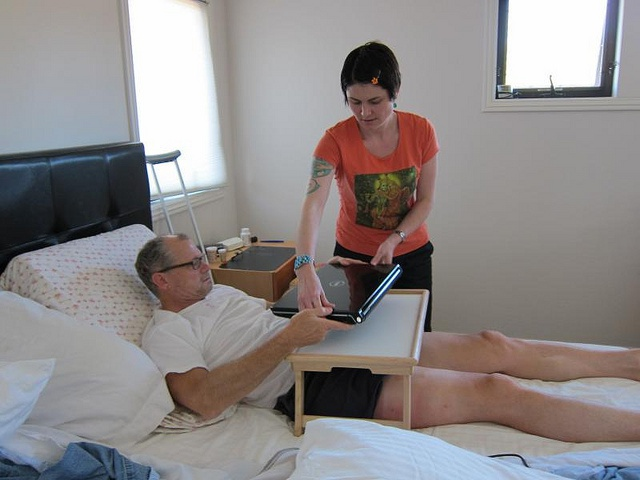Describe the objects in this image and their specific colors. I can see bed in darkgray, lightblue, and gray tones, people in darkgray, gray, and black tones, people in darkgray, black, brown, and maroon tones, laptop in darkgray, black, gray, and navy tones, and bottle in darkgray and gray tones in this image. 